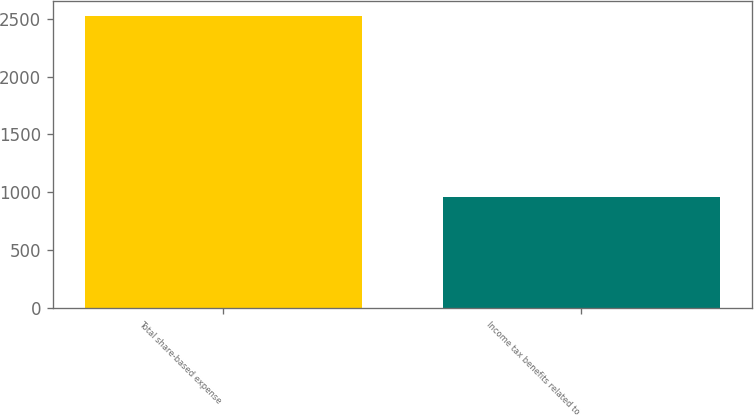Convert chart. <chart><loc_0><loc_0><loc_500><loc_500><bar_chart><fcel>Total share-based expense<fcel>Income tax benefits related to<nl><fcel>2523<fcel>959<nl></chart> 